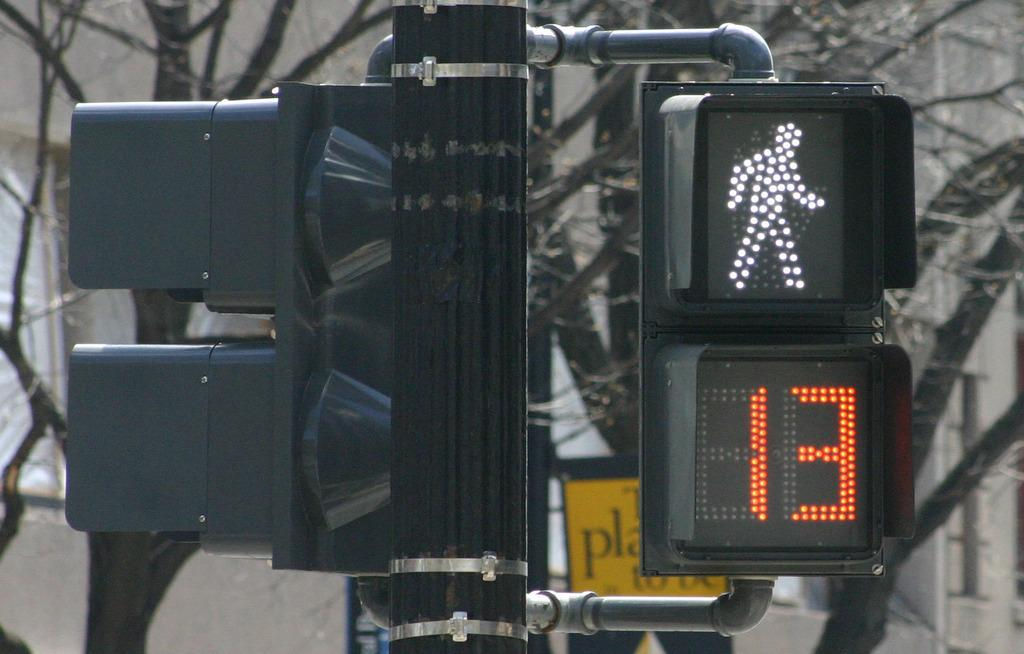<image>
Provide a brief description of the given image. a walk light has the number 13 under it in red 